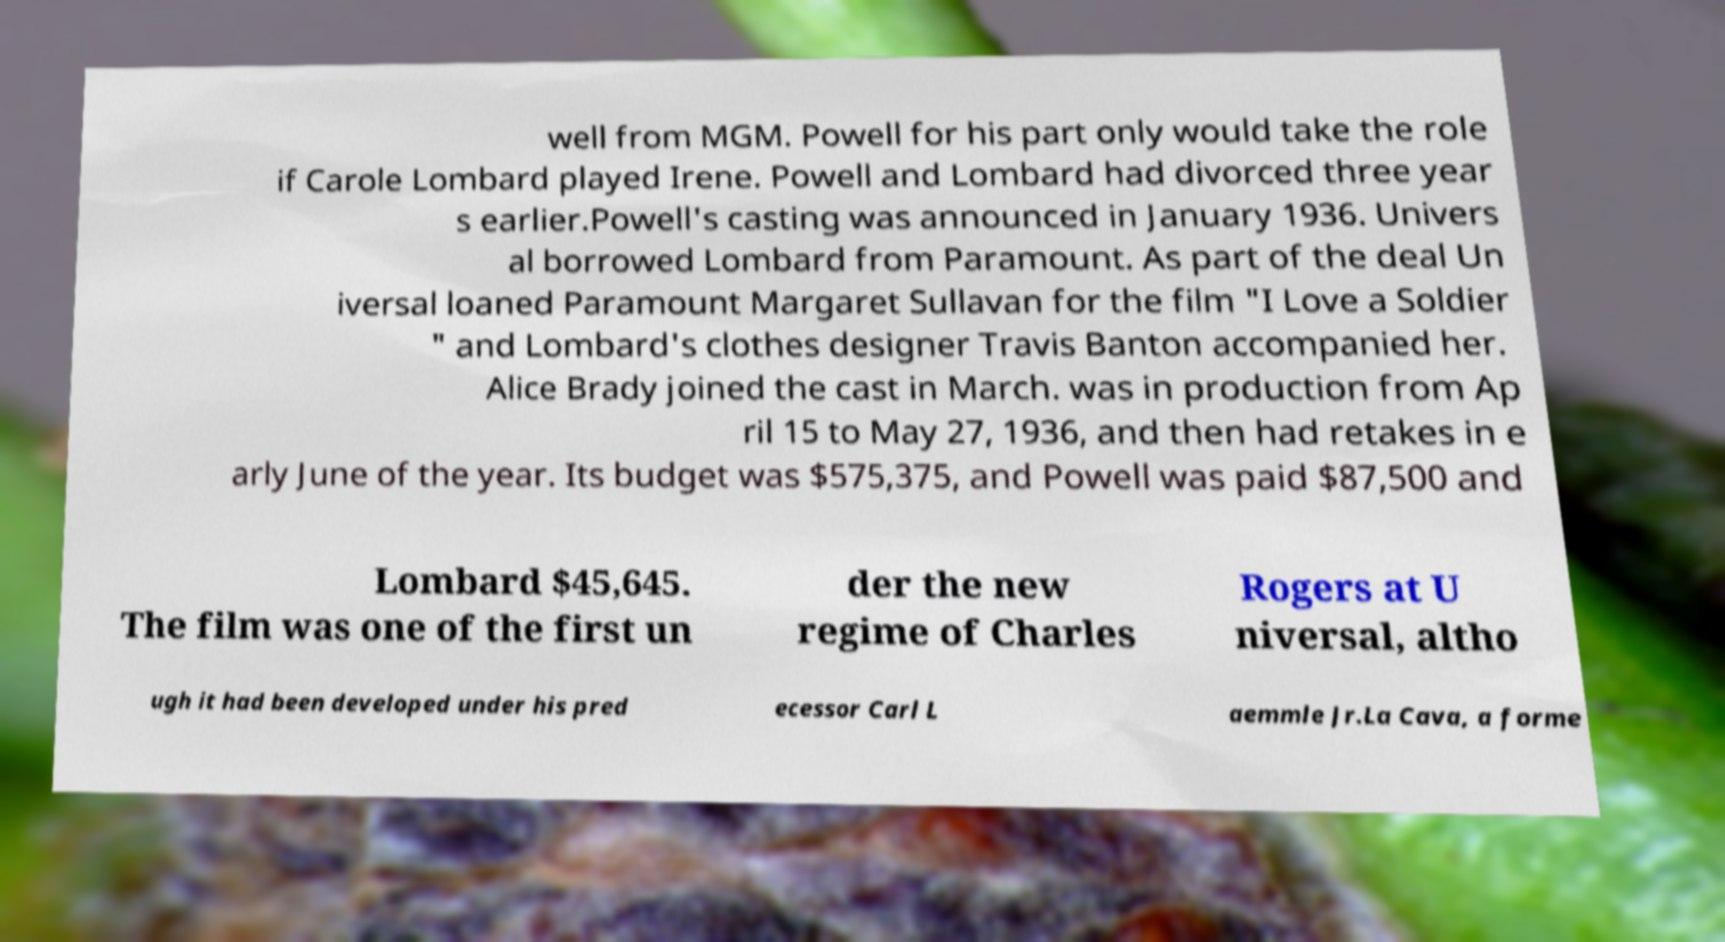There's text embedded in this image that I need extracted. Can you transcribe it verbatim? well from MGM. Powell for his part only would take the role if Carole Lombard played Irene. Powell and Lombard had divorced three year s earlier.Powell's casting was announced in January 1936. Univers al borrowed Lombard from Paramount. As part of the deal Un iversal loaned Paramount Margaret Sullavan for the film "I Love a Soldier " and Lombard's clothes designer Travis Banton accompanied her. Alice Brady joined the cast in March. was in production from Ap ril 15 to May 27, 1936, and then had retakes in e arly June of the year. Its budget was $575,375, and Powell was paid $87,500 and Lombard $45,645. The film was one of the first un der the new regime of Charles Rogers at U niversal, altho ugh it had been developed under his pred ecessor Carl L aemmle Jr.La Cava, a forme 